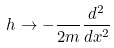<formula> <loc_0><loc_0><loc_500><loc_500>h \rightarrow - \frac { } { 2 m } \frac { d ^ { 2 } } { d x ^ { 2 } }</formula> 